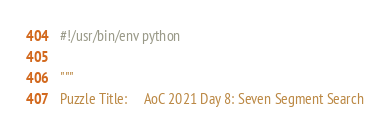Convert code to text. <code><loc_0><loc_0><loc_500><loc_500><_Python_>#!/usr/bin/env python

"""
Puzzle Title:     AoC 2021 Day 8: Seven Segment Search</code> 